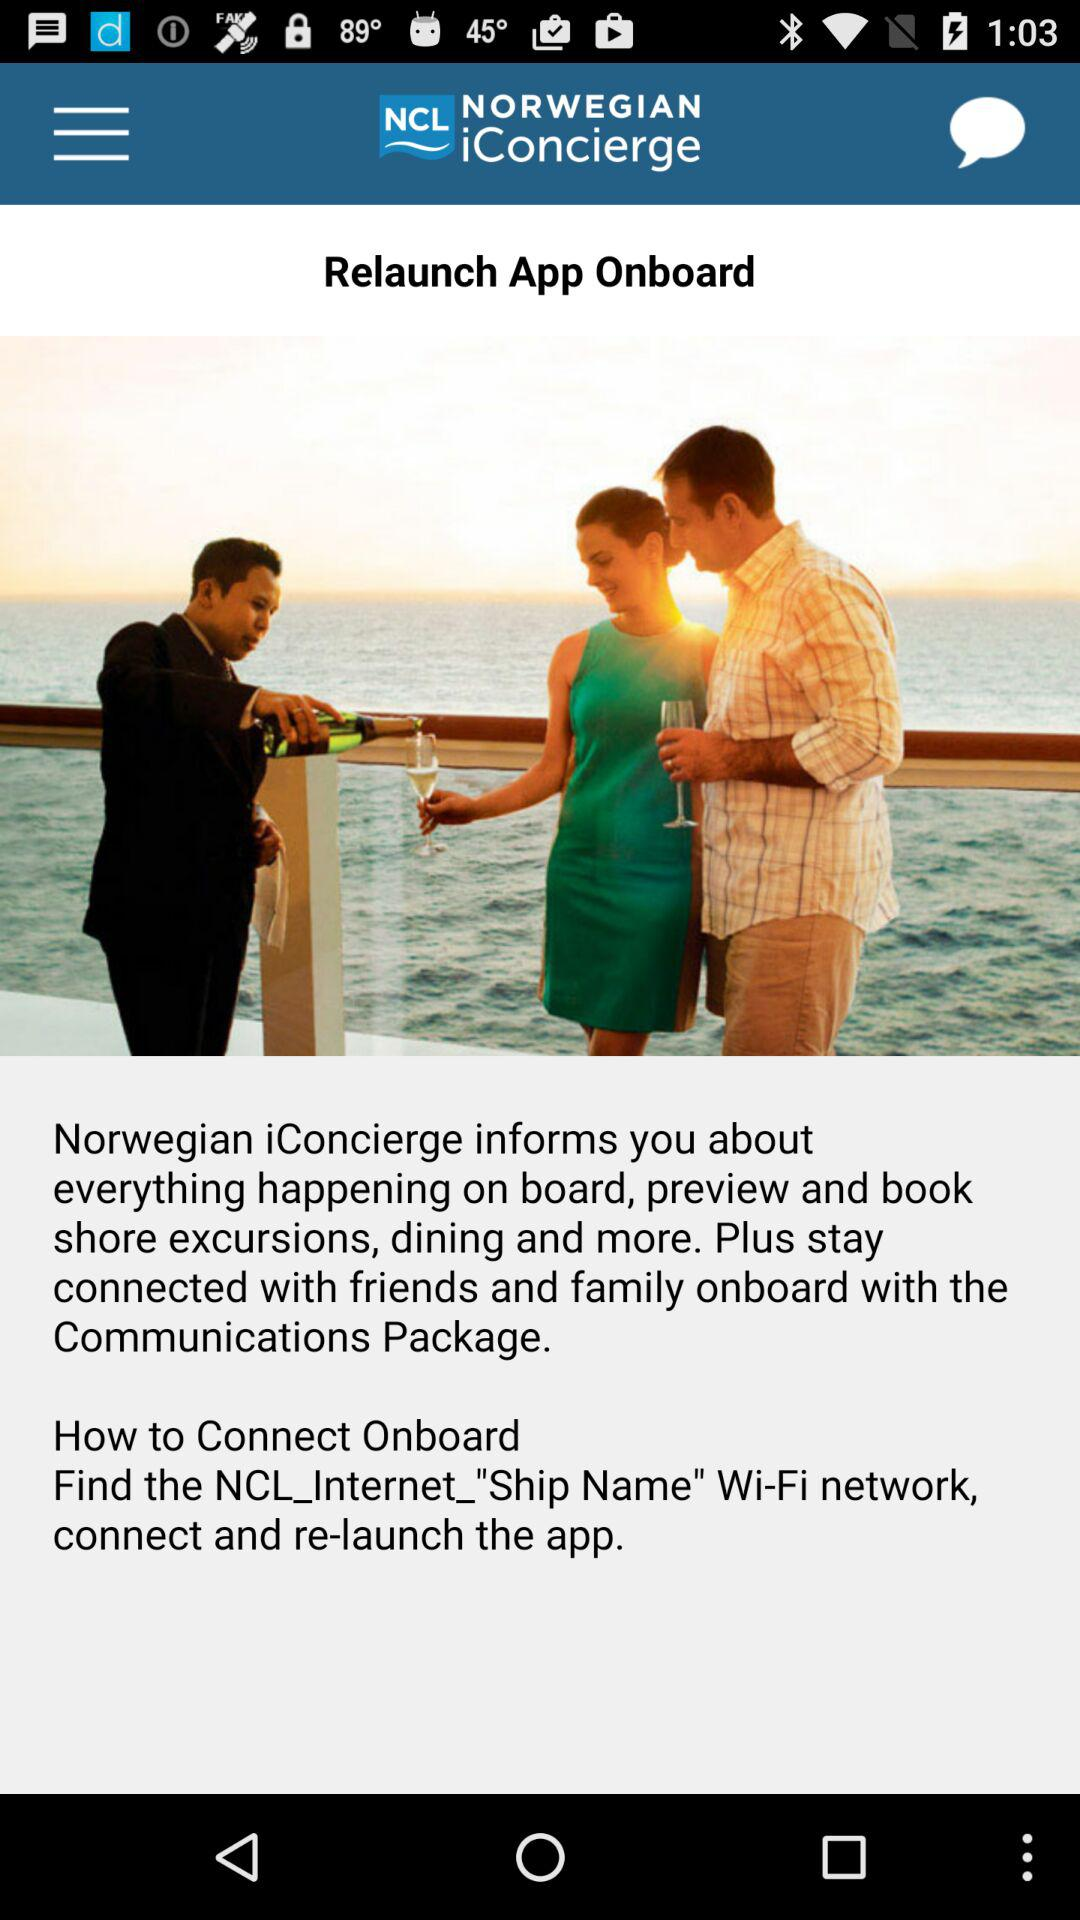What is the application name? The application name is "NORWEGIAN iConcierge". 